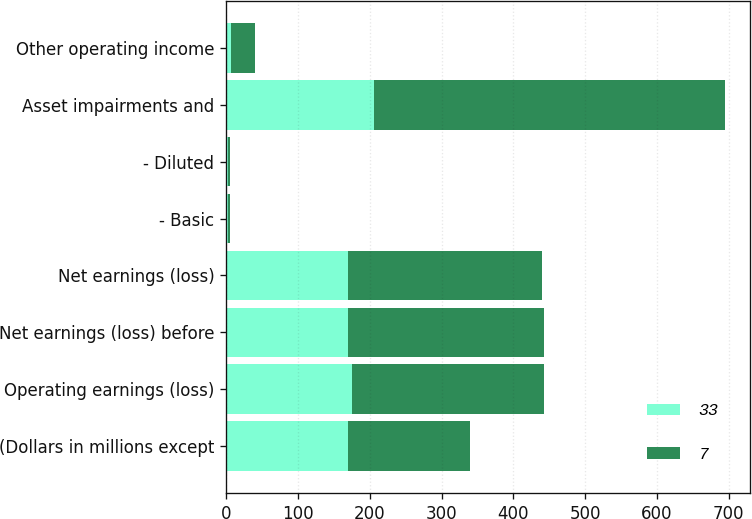Convert chart. <chart><loc_0><loc_0><loc_500><loc_500><stacked_bar_chart><ecel><fcel>(Dollars in millions except<fcel>Operating earnings (loss)<fcel>Net earnings (loss) before<fcel>Net earnings (loss)<fcel>- Basic<fcel>- Diluted<fcel>Asset impairments and<fcel>Other operating income<nl><fcel>33<fcel>170<fcel>175<fcel>170<fcel>170<fcel>2.2<fcel>2.18<fcel>206<fcel>7<nl><fcel>7<fcel>170<fcel>267<fcel>273<fcel>270<fcel>3.5<fcel>3.5<fcel>489<fcel>33<nl></chart> 